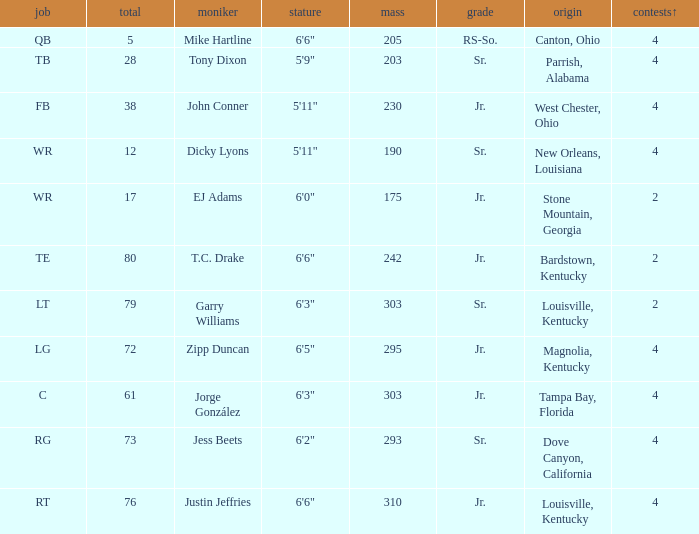Which Class has a Weight of 203? Sr. 